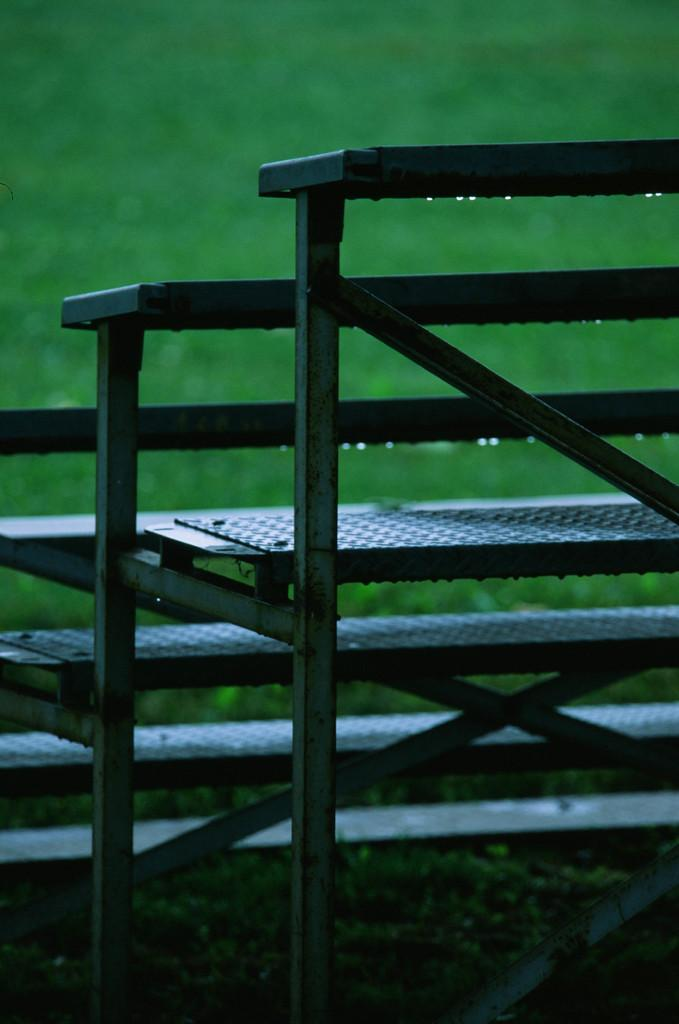What type of architectural feature is present in the image? There are steps in the image. What type of vegetation can be seen in the image? There is grass in the image. What type of pipe is visible in the image? There is no pipe present in the image. How many rocks can be seen in the image? There are no rocks visible in the image. 